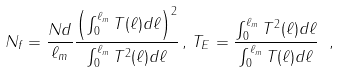<formula> <loc_0><loc_0><loc_500><loc_500>N _ { f } = \frac { N d } { \ell _ { m } } \frac { \left ( \int _ { 0 } ^ { \ell _ { m } } T ( \ell ) d \ell \right ) ^ { 2 } } { \int _ { 0 } ^ { \ell _ { m } } T ^ { 2 } ( \ell ) d \ell } \, , \, T _ { E } = \frac { \int _ { 0 } ^ { \ell _ { m } } T ^ { 2 } ( \ell ) d \ell } { \int _ { 0 } ^ { \ell _ { m } } T ( \ell ) d \ell } \ ,</formula> 